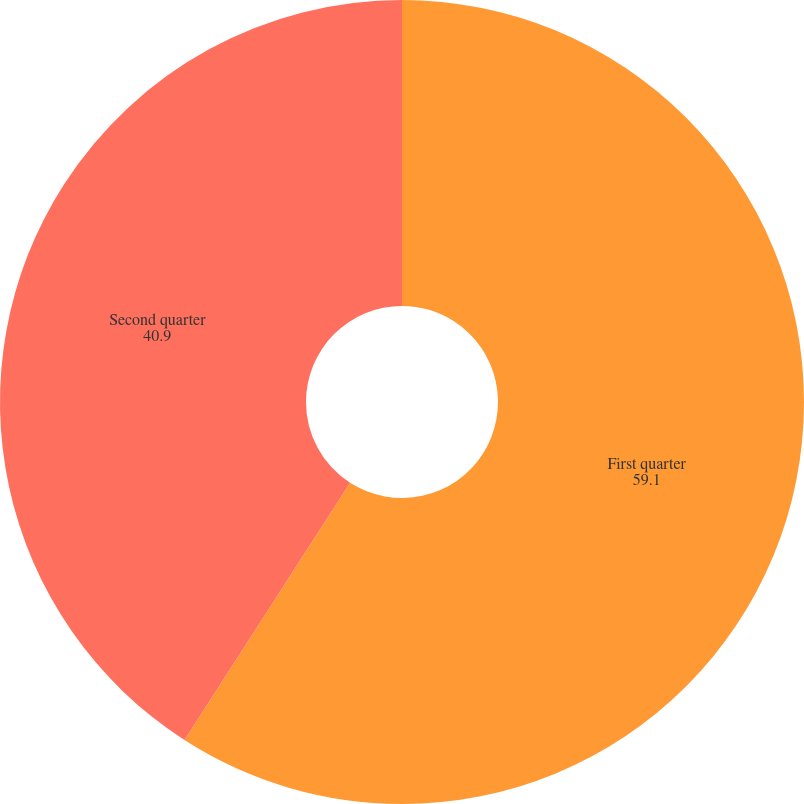<chart> <loc_0><loc_0><loc_500><loc_500><pie_chart><fcel>First quarter<fcel>Second quarter<nl><fcel>59.1%<fcel>40.9%<nl></chart> 